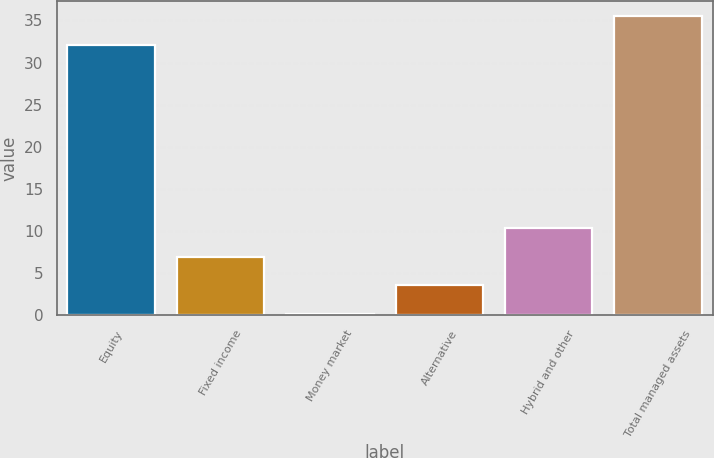Convert chart. <chart><loc_0><loc_0><loc_500><loc_500><bar_chart><fcel>Equity<fcel>Fixed income<fcel>Money market<fcel>Alternative<fcel>Hybrid and other<fcel>Total managed assets<nl><fcel>32.1<fcel>6.96<fcel>0.2<fcel>3.58<fcel>10.34<fcel>35.48<nl></chart> 